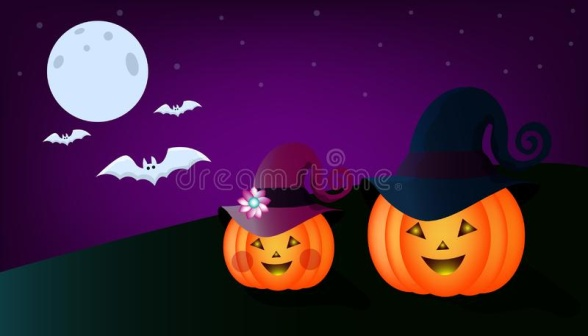What is this photo about? The image depicts a playful Halloween scene featuring two jack-o-lanterns placed on a green hill under a starry purple sky. One jack-o-lantern on the left is wearing a purple hat with a flower, while the other on the right sports a black witch's hat with a purple band. Above them, a bright full moon and three flying bats contribute to the spooky atmosphere. This charming and whimsical Halloween-themed image captures the spirit of the holiday with its delightful details and vibrant colors. 